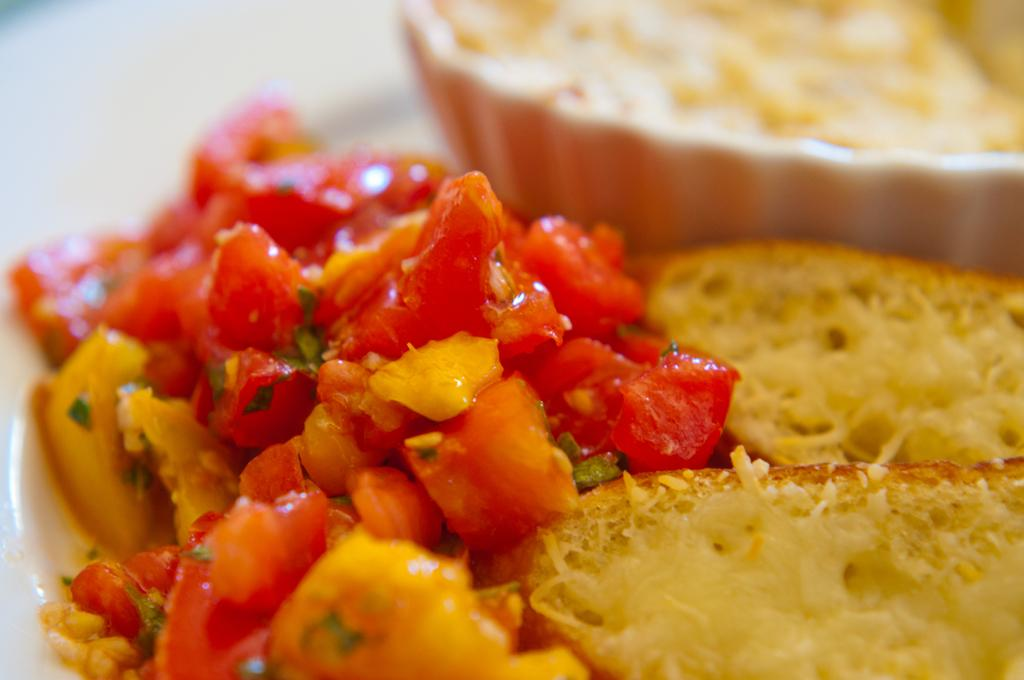What types of food items can be seen in the image? The food items include tomatoes, capsicum, and bread. Are there any other ingredients in the food items? Yes, there are other ingredients in the food items. Can you describe the background of the image? There is a bowl visible in the background of the image. How many babies can be seen playing on the farm in the image? There are no babies or farms present in the image; it features food items and a bowl in the background. 